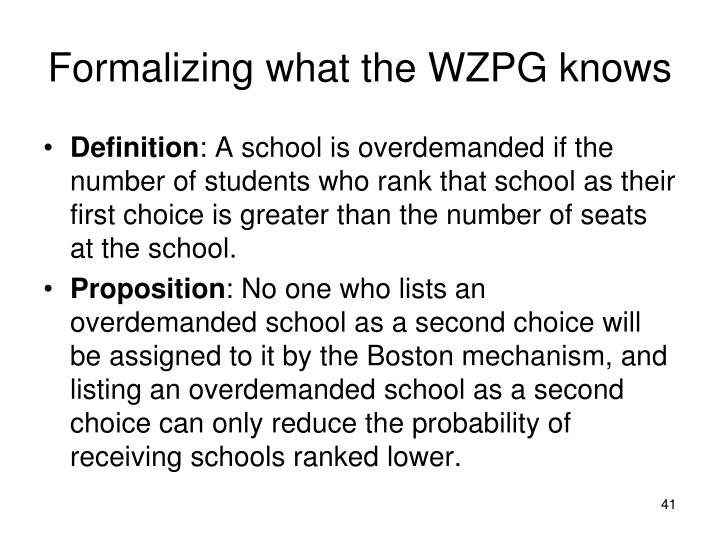Could you elaborate on how understanding school demand statistics could possibly change a student’s ranking strategy? Understanding the demand statistics for each school can significantly influence a student's ranking strategy under the Boston mechanism. If a student knows that certain schools traditionally have high demand versus the number of available seats, they can strategize to avoid placing such schools as their second choice or below, opting instead for schools where their application would be more competitive. Moreover, this insight allows the student to rank schools realistically, maximizing their admissions chances while still aiming for top preferences where they might have a competitive edge. 